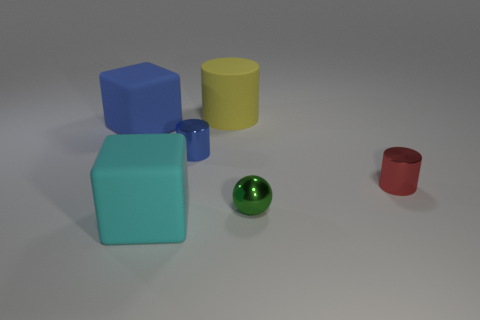Which object is the smallest, and does its color appear anywhere else in the scene? The red cup is the smallest object. Its color is unique to this item within the scene and does not appear on any other object. 